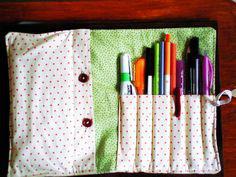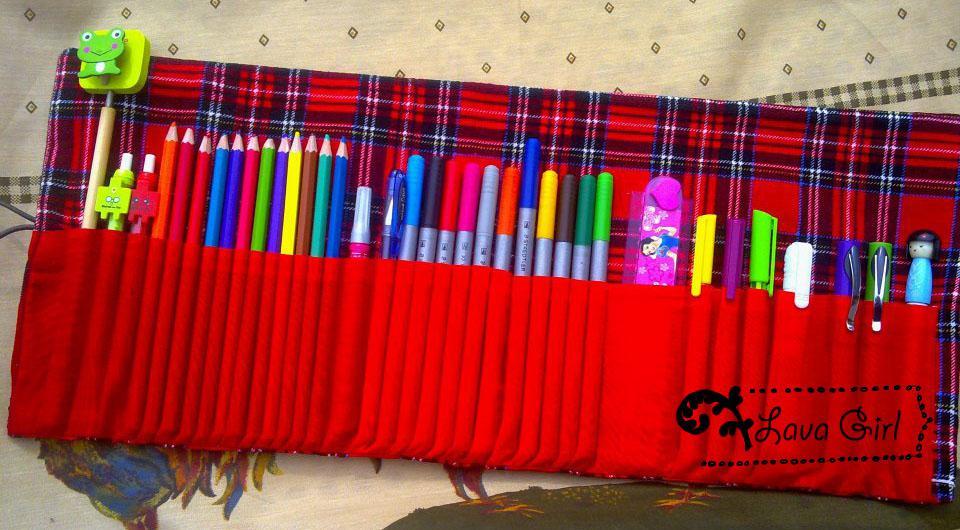The first image is the image on the left, the second image is the image on the right. Analyze the images presented: Is the assertion "One image shows an unrolled pencil case with a solid red and tartan plaid interior, and the other shows a case with a small printed pattern on its interior." valid? Answer yes or no. Yes. The first image is the image on the left, the second image is the image on the right. Evaluate the accuracy of this statement regarding the images: "In one image, a red plaid pencil case is unrolled, revealing a long red pocket that contains a collection of pencils, markers, pens, and a green frog eraser.". Is it true? Answer yes or no. Yes. 